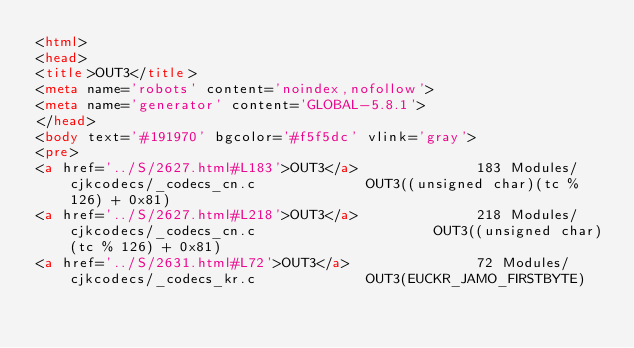<code> <loc_0><loc_0><loc_500><loc_500><_HTML_><html>
<head>
<title>OUT3</title>
<meta name='robots' content='noindex,nofollow'>
<meta name='generator' content='GLOBAL-5.8.1'>
</head>
<body text='#191970' bgcolor='#f5f5dc' vlink='gray'>
<pre>
<a href='../S/2627.html#L183'>OUT3</a>              183 Modules/cjkcodecs/_codecs_cn.c             OUT3((unsigned char)(tc % 126) + 0x81)
<a href='../S/2627.html#L218'>OUT3</a>              218 Modules/cjkcodecs/_codecs_cn.c                     OUT3((unsigned char)(tc % 126) + 0x81)
<a href='../S/2631.html#L72'>OUT3</a>               72 Modules/cjkcodecs/_codecs_kr.c             OUT3(EUCKR_JAMO_FIRSTBYTE)</code> 